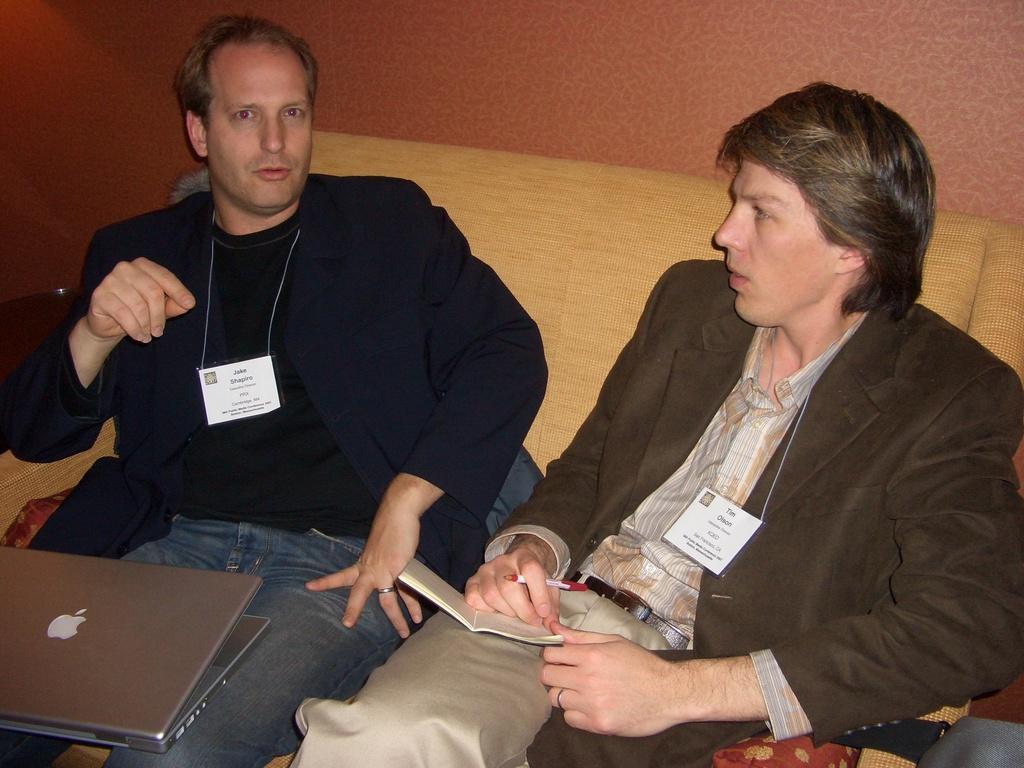How would you summarize this image in a sentence or two? In this image there are two persons wearing identity cards and sitting on the sofa. Image also consists of a laptop and one person is holding a pen and a book. In the background there is a plain wall. 